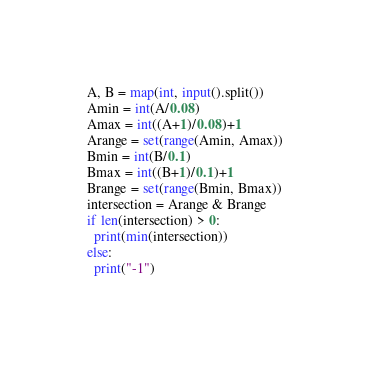<code> <loc_0><loc_0><loc_500><loc_500><_Python_>A, B = map(int, input().split())
Amin = int(A/0.08)
Amax = int((A+1)/0.08)+1
Arange = set(range(Amin, Amax))
Bmin = int(B/0.1)
Bmax = int((B+1)/0.1)+1
Brange = set(range(Bmin, Bmax))
intersection = Arange & Brange
if len(intersection) > 0:
  print(min(intersection))
else:
  print("-1")</code> 